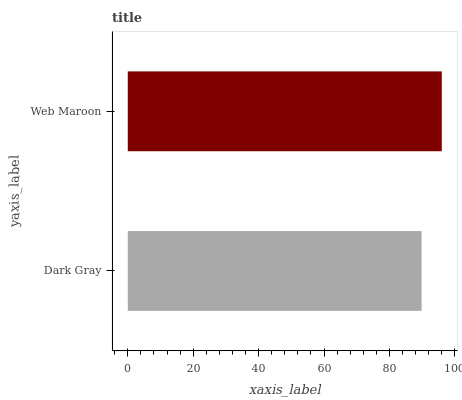Is Dark Gray the minimum?
Answer yes or no. Yes. Is Web Maroon the maximum?
Answer yes or no. Yes. Is Web Maroon the minimum?
Answer yes or no. No. Is Web Maroon greater than Dark Gray?
Answer yes or no. Yes. Is Dark Gray less than Web Maroon?
Answer yes or no. Yes. Is Dark Gray greater than Web Maroon?
Answer yes or no. No. Is Web Maroon less than Dark Gray?
Answer yes or no. No. Is Web Maroon the high median?
Answer yes or no. Yes. Is Dark Gray the low median?
Answer yes or no. Yes. Is Dark Gray the high median?
Answer yes or no. No. Is Web Maroon the low median?
Answer yes or no. No. 